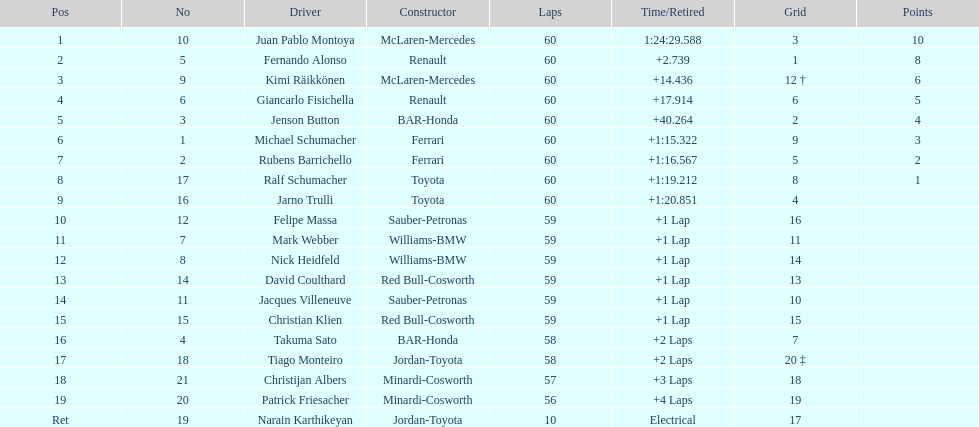After 8th position, how many points does a driver receive? 0. 